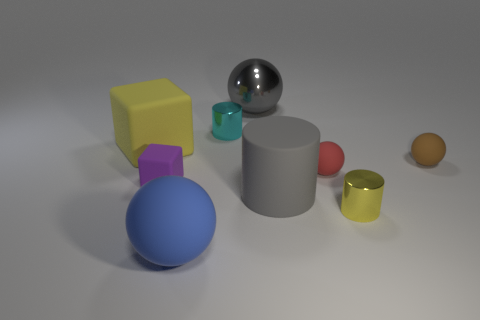Is the size of the gray thing that is in front of the brown matte thing the same as the small purple matte cube?
Your answer should be compact. No. Does the large metallic ball have the same color as the big matte cylinder?
Offer a very short reply. Yes. What size is the cylinder that is the same color as the big rubber block?
Your response must be concise. Small. There is a metal cylinder that is on the right side of the large gray object left of the big gray rubber object that is right of the big rubber ball; what is its color?
Your answer should be very brief. Yellow. How many yellow things are either large matte cylinders or big spheres?
Offer a very short reply. 0. What number of other big things have the same shape as the blue object?
Offer a very short reply. 1. There is a gray thing that is the same size as the gray rubber cylinder; what shape is it?
Offer a terse response. Sphere. Are there any gray spheres in front of the large yellow matte object?
Ensure brevity in your answer.  No. Is there a red rubber ball behind the small shiny thing behind the tiny red rubber object?
Offer a very short reply. No. Are there fewer tiny purple rubber objects that are behind the small purple matte block than big matte cubes in front of the large rubber ball?
Offer a very short reply. No. 